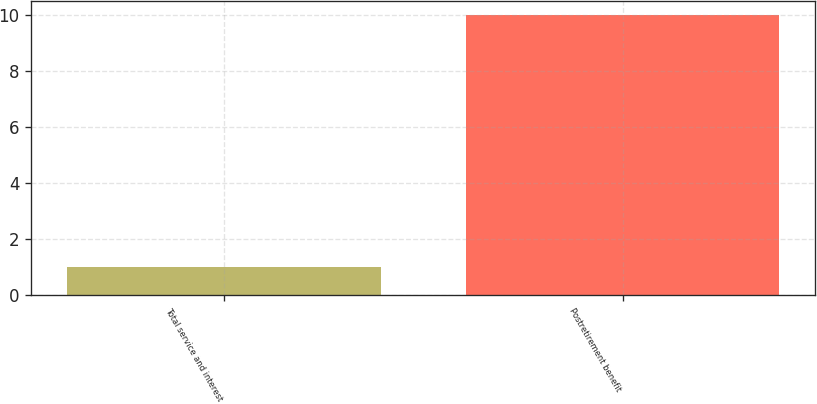Convert chart. <chart><loc_0><loc_0><loc_500><loc_500><bar_chart><fcel>Total service and interest<fcel>Postretirement benefit<nl><fcel>1<fcel>10<nl></chart> 